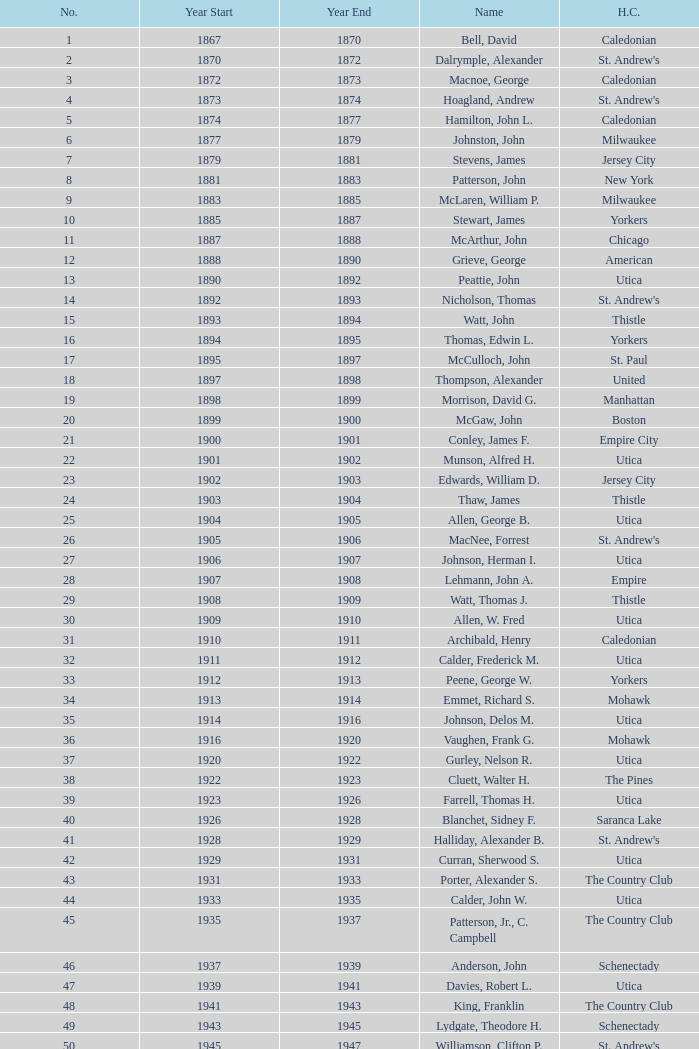Which Number has a Home Club of broomstones, and a Year End smaller than 1999? None. Help me parse the entirety of this table. {'header': ['No.', 'Year Start', 'Year End', 'Name', 'H.C.'], 'rows': [['1', '1867', '1870', 'Bell, David', 'Caledonian'], ['2', '1870', '1872', 'Dalrymple, Alexander', "St. Andrew's"], ['3', '1872', '1873', 'Macnoe, George', 'Caledonian'], ['4', '1873', '1874', 'Hoagland, Andrew', "St. Andrew's"], ['5', '1874', '1877', 'Hamilton, John L.', 'Caledonian'], ['6', '1877', '1879', 'Johnston, John', 'Milwaukee'], ['7', '1879', '1881', 'Stevens, James', 'Jersey City'], ['8', '1881', '1883', 'Patterson, John', 'New York'], ['9', '1883', '1885', 'McLaren, William P.', 'Milwaukee'], ['10', '1885', '1887', 'Stewart, James', 'Yorkers'], ['11', '1887', '1888', 'McArthur, John', 'Chicago'], ['12', '1888', '1890', 'Grieve, George', 'American'], ['13', '1890', '1892', 'Peattie, John', 'Utica'], ['14', '1892', '1893', 'Nicholson, Thomas', "St. Andrew's"], ['15', '1893', '1894', 'Watt, John', 'Thistle'], ['16', '1894', '1895', 'Thomas, Edwin L.', 'Yorkers'], ['17', '1895', '1897', 'McCulloch, John', 'St. Paul'], ['18', '1897', '1898', 'Thompson, Alexander', 'United'], ['19', '1898', '1899', 'Morrison, David G.', 'Manhattan'], ['20', '1899', '1900', 'McGaw, John', 'Boston'], ['21', '1900', '1901', 'Conley, James F.', 'Empire City'], ['22', '1901', '1902', 'Munson, Alfred H.', 'Utica'], ['23', '1902', '1903', 'Edwards, William D.', 'Jersey City'], ['24', '1903', '1904', 'Thaw, James', 'Thistle'], ['25', '1904', '1905', 'Allen, George B.', 'Utica'], ['26', '1905', '1906', 'MacNee, Forrest', "St. Andrew's"], ['27', '1906', '1907', 'Johnson, Herman I.', 'Utica'], ['28', '1907', '1908', 'Lehmann, John A.', 'Empire'], ['29', '1908', '1909', 'Watt, Thomas J.', 'Thistle'], ['30', '1909', '1910', 'Allen, W. Fred', 'Utica'], ['31', '1910', '1911', 'Archibald, Henry', 'Caledonian'], ['32', '1911', '1912', 'Calder, Frederick M.', 'Utica'], ['33', '1912', '1913', 'Peene, George W.', 'Yorkers'], ['34', '1913', '1914', 'Emmet, Richard S.', 'Mohawk'], ['35', '1914', '1916', 'Johnson, Delos M.', 'Utica'], ['36', '1916', '1920', 'Vaughen, Frank G.', 'Mohawk'], ['37', '1920', '1922', 'Gurley, Nelson R.', 'Utica'], ['38', '1922', '1923', 'Cluett, Walter H.', 'The Pines'], ['39', '1923', '1926', 'Farrell, Thomas H.', 'Utica'], ['40', '1926', '1928', 'Blanchet, Sidney F.', 'Saranca Lake'], ['41', '1928', '1929', 'Halliday, Alexander B.', "St. Andrew's"], ['42', '1929', '1931', 'Curran, Sherwood S.', 'Utica'], ['43', '1931', '1933', 'Porter, Alexander S.', 'The Country Club'], ['44', '1933', '1935', 'Calder, John W.', 'Utica'], ['45', '1935', '1937', 'Patterson, Jr., C. Campbell', 'The Country Club'], ['46', '1937', '1939', 'Anderson, John', 'Schenectady'], ['47', '1939', '1941', 'Davies, Robert L.', 'Utica'], ['48', '1941', '1943', 'King, Franklin', 'The Country Club'], ['49', '1943', '1945', 'Lydgate, Theodore H.', 'Schenectady'], ['50', '1945', '1947', 'Williamson, Clifton P.', "St. Andrew's"], ['51', '1947', '1949', 'Hurd, Kenneth S.', 'Utica'], ['52', '1949', '1951', 'Hastings, Addison B.', 'Ardsley'], ['53', '1951', '1953', 'Hill, Lucius T.', 'The Country Club'], ['54', '1953', '1954', 'Davis, Richard P.', 'Schenectady'], ['55', '1954', '1956', 'Joy, John H.', 'Winchester'], ['56', '1956', '1957', 'Searle, William A.', 'Utica'], ['57', '1957', '1958', 'Smith, Dr. Deering G.', 'Nashua'], ['58', '1958', '1959', 'Seibert, W. Lincoln', "St. Andrew's"], ['59', '1959', '1961', 'Reid, Ralston B.', 'Schenectady'], ['60', '1961', '1963', 'Cushing, Henry K.', 'The Country Club'], ['61', '1963', '1965', 'Wood, Brenner R.', 'Ardsley'], ['62', '1965', '1966', 'Parkinson, Fred E.', 'Utica'], ['63', '1966', '1968', 'Childs, Edward C.', 'Norfolk'], ['64', '1968', '1970', 'Rand, Grenfell N.', 'Albany'], ['65', '1970', '1972', 'Neill, Stanley E.', 'Winchester'], ['66', '1972', '1974', 'Milano, Dr. Joseph E.', 'NY Caledonian'], ['67', '1974', '1976', 'Neuber, Dr. Richard A.', 'Schenectady'], ['68', '1976', '1978', 'Cobb, Arthur J.', 'Utica'], ['69', '1978', '1980', 'Hamm, Arthur E.', 'Petersham'], ['70', '1980', '1982', 'Will, A. Roland', 'Nutmeg'], ['71', '1982', '1984', 'Cooper, C. Kenneth', 'NY Caledonian'], ['72', '1984', '1986', 'Porter, David R.', 'Wellesley'], ['73', '1984', '1986', 'Millington, A. Wesley', 'Schenectady'], ['74', '1988', '1989', 'Dewees, Dr. David C.', 'Cape Cod'], ['75', '1989', '1991', 'Owens, Charles D.', 'Nutmeg'], ['76', '1991', '1993', 'Mitchell, J. Peter', 'Garden State'], ['77', '1993', '1995', 'Lopez, Jr., Chester H.', 'Nashua'], ['78', '1995', '1997', 'Freeman, Kim', 'Schenectady'], ['79', '1997', '1999', 'Williams, Samuel C.', 'Broomstones'], ['80', '1999', '2001', 'Hatch, Peggy', 'Philadelphia'], ['81', '2001', '2003', 'Garber, Thomas', 'Utica'], ['82', '2003', '2005', 'Pelletier, Robert', 'Potomac'], ['83', '2005', '2007', 'Chandler, Robert P.', 'Broomstones'], ['84', '2007', '2009', 'Krailo, Gwen', 'Nashua'], ['85', '2009', '2011', 'Thomas, Carl', 'Utica'], ['86', '2011', '2013', 'Macartney, Dick', 'Coastal Carolina']]} 